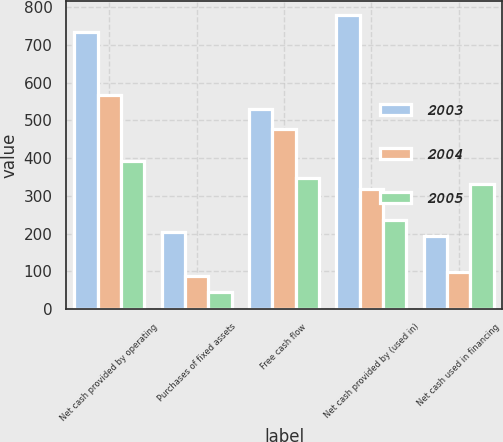Convert chart. <chart><loc_0><loc_0><loc_500><loc_500><stacked_bar_chart><ecel><fcel>Net cash provided by operating<fcel>Purchases of fixed assets<fcel>Free cash flow<fcel>Net cash provided by (used in)<fcel>Net cash used in financing<nl><fcel>2003<fcel>733<fcel>204<fcel>529<fcel>778<fcel>193<nl><fcel>2004<fcel>566<fcel>89<fcel>477<fcel>317<fcel>97<nl><fcel>2005<fcel>393<fcel>46<fcel>347<fcel>236<fcel>332<nl></chart> 